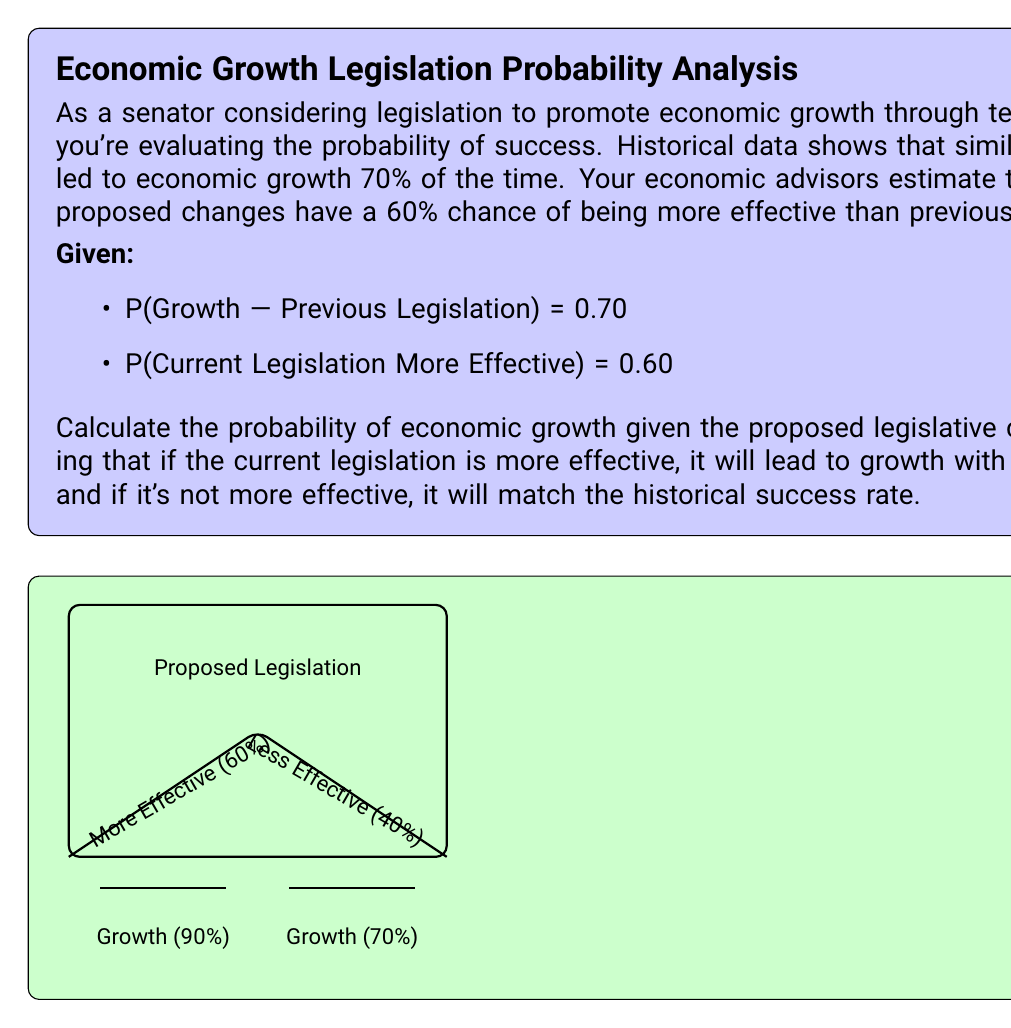Show me your answer to this math problem. Let's approach this step-by-step using Bayesian probability:

1) Define events:
   A: Economic growth occurs
   B: Current legislation is more effective

2) We need to calculate P(A), which can be done using the law of total probability:

   P(A) = P(A|B) * P(B) + P(A|not B) * P(not B)

3) Given:
   P(B) = 0.60
   P(not B) = 1 - P(B) = 0.40
   P(A|B) = 0.90
   P(A|not B) = 0.70 (same as historical rate)

4) Plug into the formula:

   P(A) = 0.90 * 0.60 + 0.70 * 0.40

5) Calculate:
   P(A) = 0.54 + 0.28 = 0.82

6) Convert to percentage:
   0.82 * 100 = 82%

Therefore, the probability of economic growth given the proposed legislative changes is 82%.
Answer: 82% 